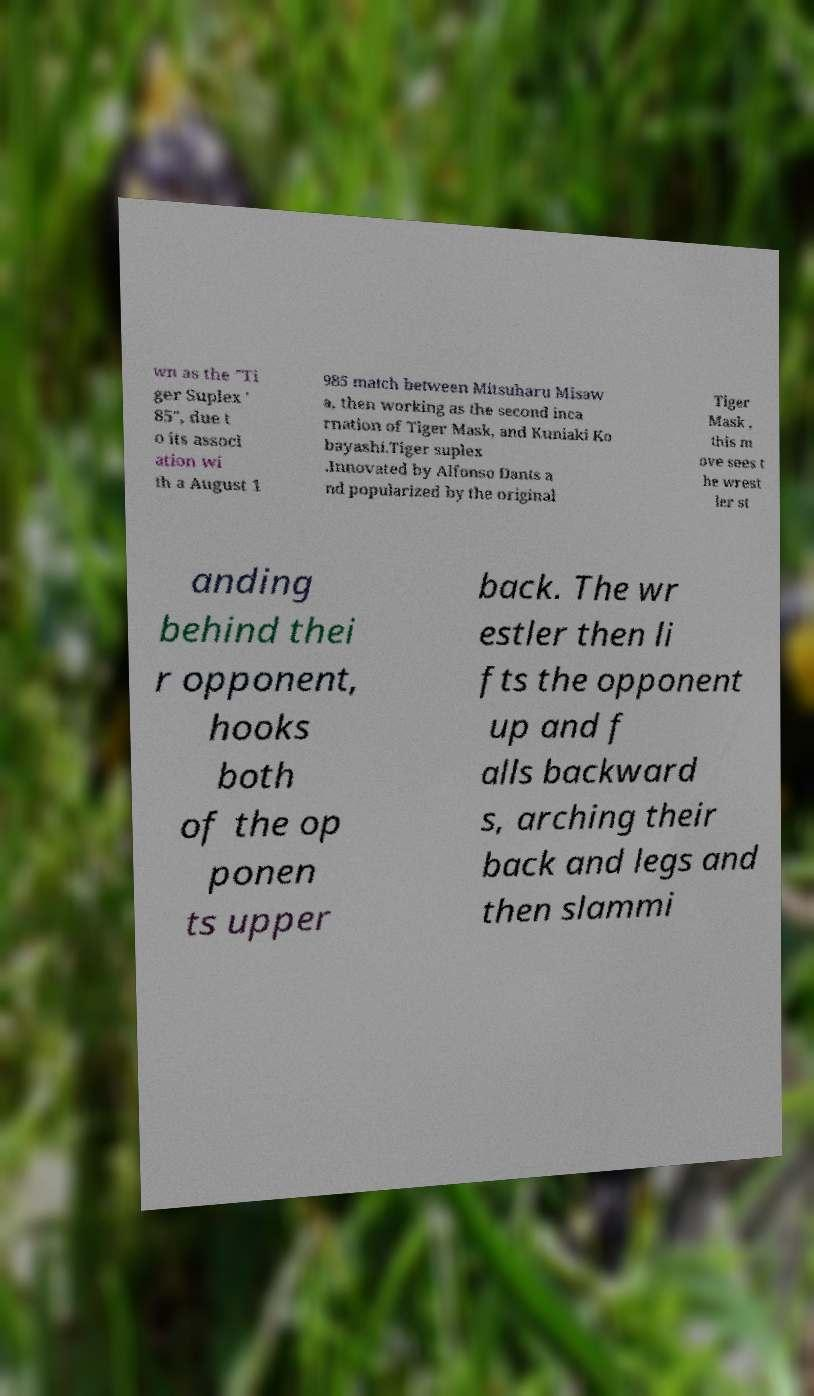Please identify and transcribe the text found in this image. wn as the "Ti ger Suplex ' 85", due t o its associ ation wi th a August 1 985 match between Mitsuharu Misaw a, then working as the second inca rnation of Tiger Mask, and Kuniaki Ko bayashi.Tiger suplex .Innovated by Alfonso Dants a nd popularized by the original Tiger Mask , this m ove sees t he wrest ler st anding behind thei r opponent, hooks both of the op ponen ts upper back. The wr estler then li fts the opponent up and f alls backward s, arching their back and legs and then slammi 